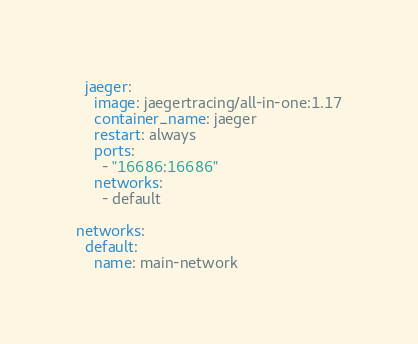Convert code to text. <code><loc_0><loc_0><loc_500><loc_500><_YAML_>  jaeger:
    image: jaegertracing/all-in-one:1.17
    container_name: jaeger
    restart: always
    ports:
      - "16686:16686"
    networks:
      - default

networks:
  default:  
    name: main-network




</code> 